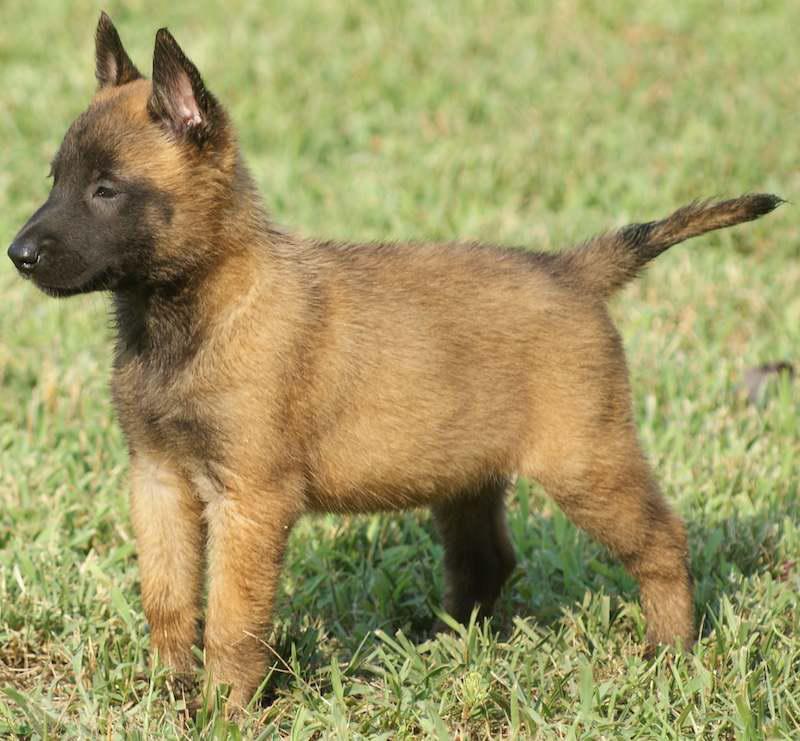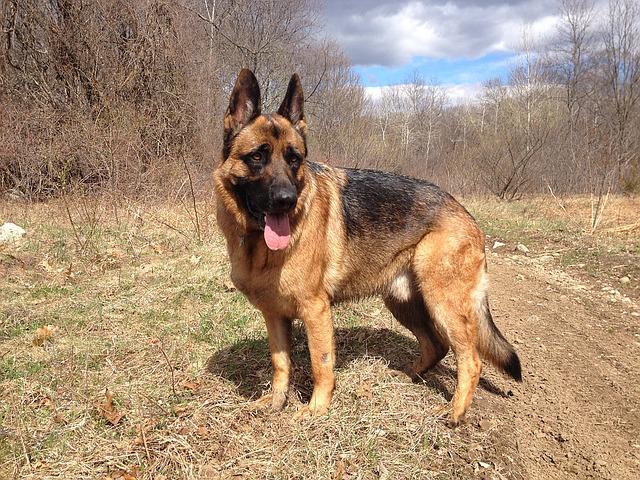The first image is the image on the left, the second image is the image on the right. For the images shown, is this caption "There is a dog looking off to the left." true? Answer yes or no. Yes. 